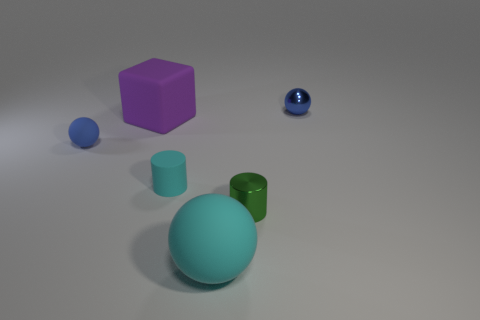How many objects can you see in this image? I can see five objects. They include a large sphere, a smaller sphere, a cylinder, a cube, and a small shiny sphere.  What colors are the objects? The large sphere is a light turquoise color, the smaller sphere and the cube are both shades of purple, the cylinder is green, and the smallest shiny sphere is blue. 